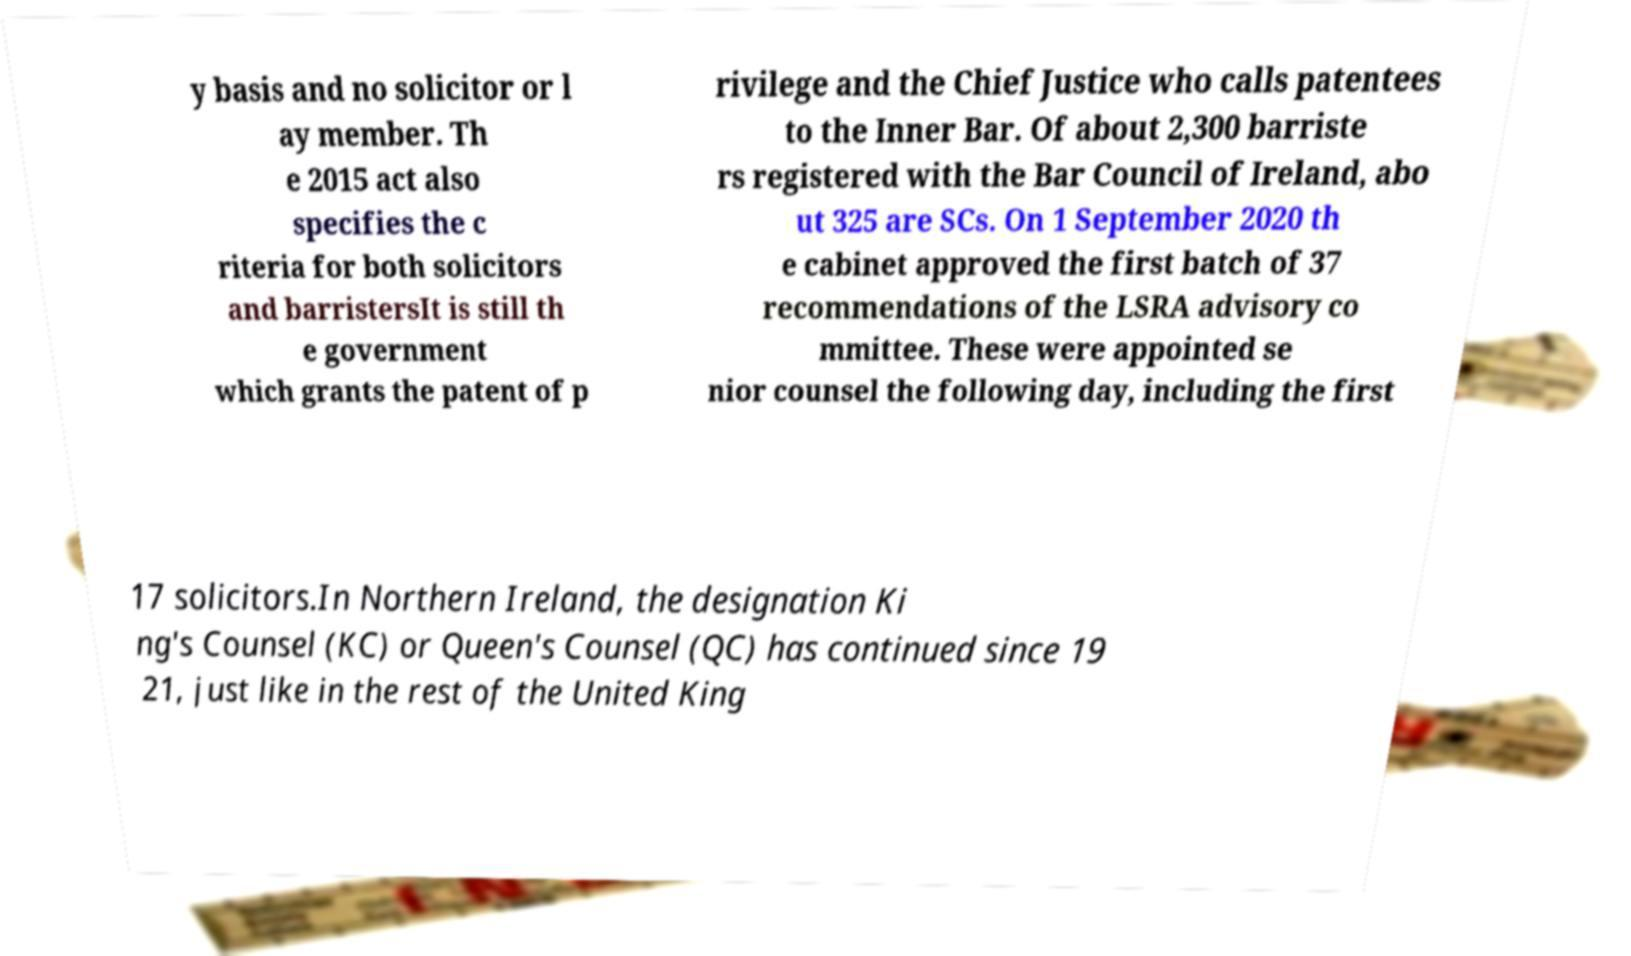Can you read and provide the text displayed in the image?This photo seems to have some interesting text. Can you extract and type it out for me? y basis and no solicitor or l ay member. Th e 2015 act also specifies the c riteria for both solicitors and barristersIt is still th e government which grants the patent of p rivilege and the Chief Justice who calls patentees to the Inner Bar. Of about 2,300 barriste rs registered with the Bar Council of Ireland, abo ut 325 are SCs. On 1 September 2020 th e cabinet approved the first batch of 37 recommendations of the LSRA advisory co mmittee. These were appointed se nior counsel the following day, including the first 17 solicitors.In Northern Ireland, the designation Ki ng's Counsel (KC) or Queen's Counsel (QC) has continued since 19 21, just like in the rest of the United King 